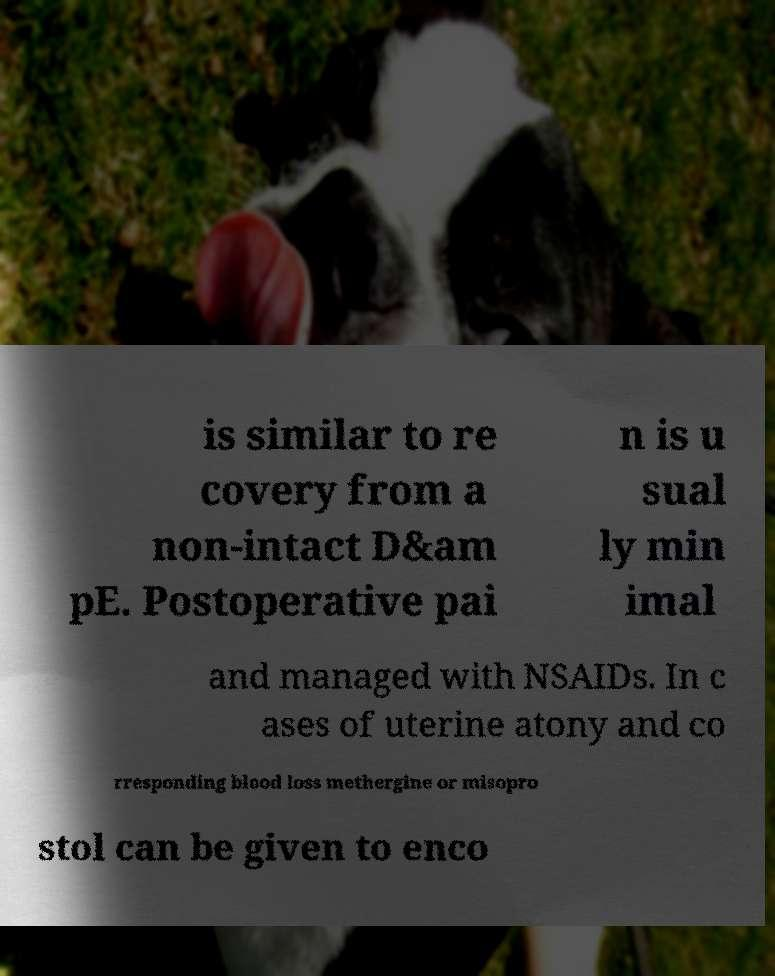I need the written content from this picture converted into text. Can you do that? is similar to re covery from a non-intact D&am pE. Postoperative pai n is u sual ly min imal and managed with NSAIDs. In c ases of uterine atony and co rresponding blood loss methergine or misopro stol can be given to enco 